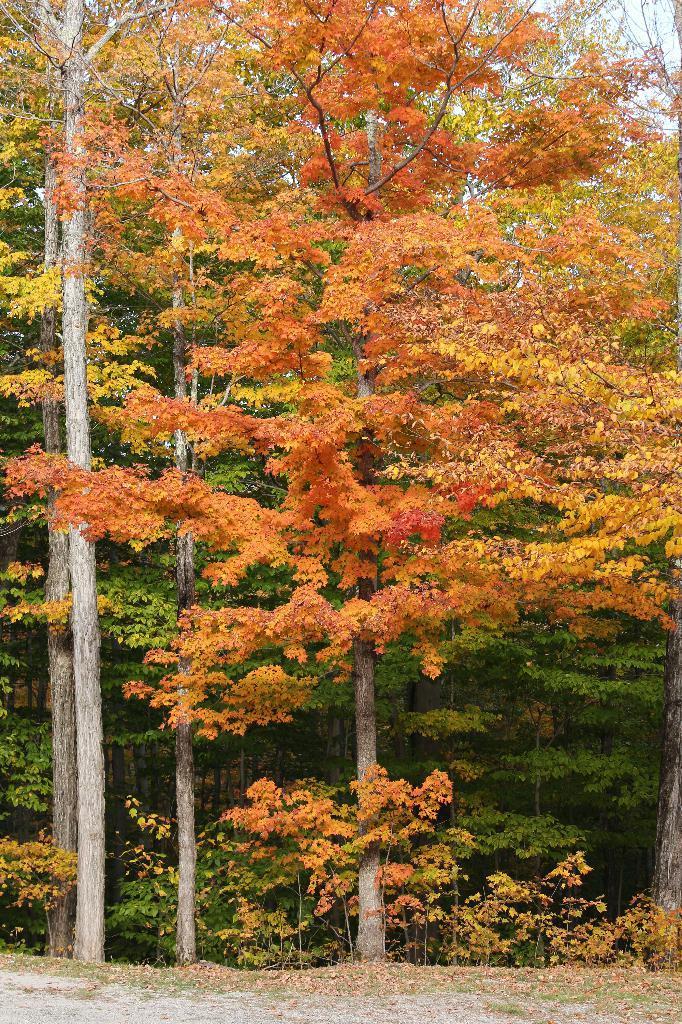Can you describe this image briefly? In this image there is the sky towards the top of the image, there are trees, there are plants, there is ground towards the bottom of the image. 